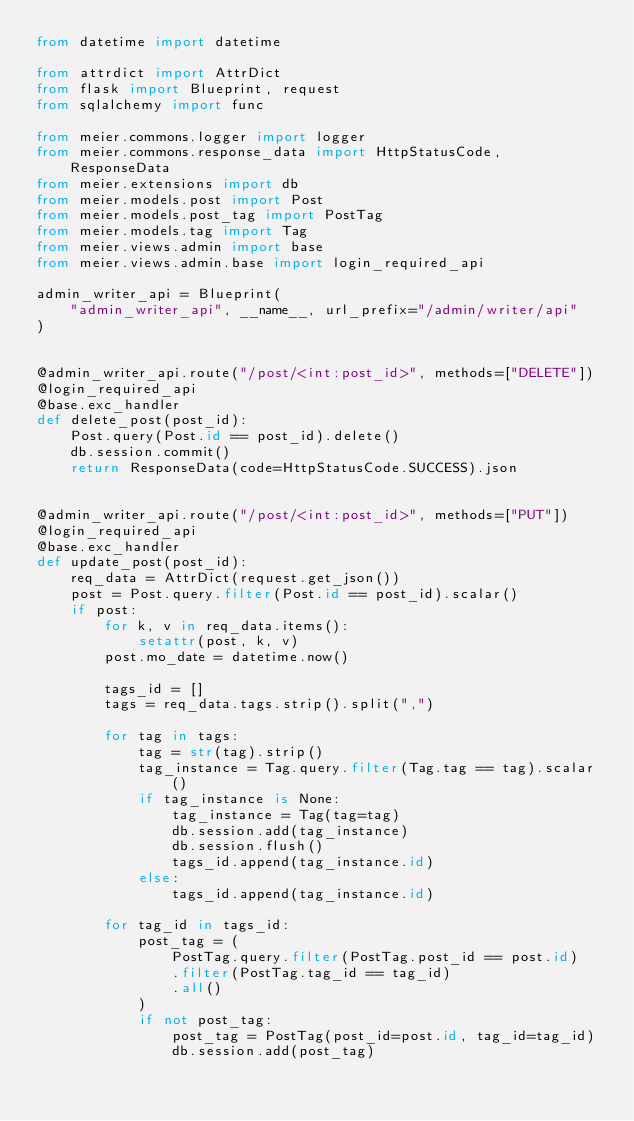<code> <loc_0><loc_0><loc_500><loc_500><_Python_>from datetime import datetime

from attrdict import AttrDict
from flask import Blueprint, request
from sqlalchemy import func

from meier.commons.logger import logger
from meier.commons.response_data import HttpStatusCode, ResponseData
from meier.extensions import db
from meier.models.post import Post
from meier.models.post_tag import PostTag
from meier.models.tag import Tag
from meier.views.admin import base
from meier.views.admin.base import login_required_api

admin_writer_api = Blueprint(
    "admin_writer_api", __name__, url_prefix="/admin/writer/api"
)


@admin_writer_api.route("/post/<int:post_id>", methods=["DELETE"])
@login_required_api
@base.exc_handler
def delete_post(post_id):
    Post.query(Post.id == post_id).delete()
    db.session.commit()
    return ResponseData(code=HttpStatusCode.SUCCESS).json


@admin_writer_api.route("/post/<int:post_id>", methods=["PUT"])
@login_required_api
@base.exc_handler
def update_post(post_id):
    req_data = AttrDict(request.get_json())
    post = Post.query.filter(Post.id == post_id).scalar()
    if post:
        for k, v in req_data.items():
            setattr(post, k, v)
        post.mo_date = datetime.now()

        tags_id = []
        tags = req_data.tags.strip().split(",")

        for tag in tags:
            tag = str(tag).strip()
            tag_instance = Tag.query.filter(Tag.tag == tag).scalar()
            if tag_instance is None:
                tag_instance = Tag(tag=tag)
                db.session.add(tag_instance)
                db.session.flush()
                tags_id.append(tag_instance.id)
            else:
                tags_id.append(tag_instance.id)

        for tag_id in tags_id:
            post_tag = (
                PostTag.query.filter(PostTag.post_id == post.id)
                .filter(PostTag.tag_id == tag_id)
                .all()
            )
            if not post_tag:
                post_tag = PostTag(post_id=post.id, tag_id=tag_id)
                db.session.add(post_tag)</code> 